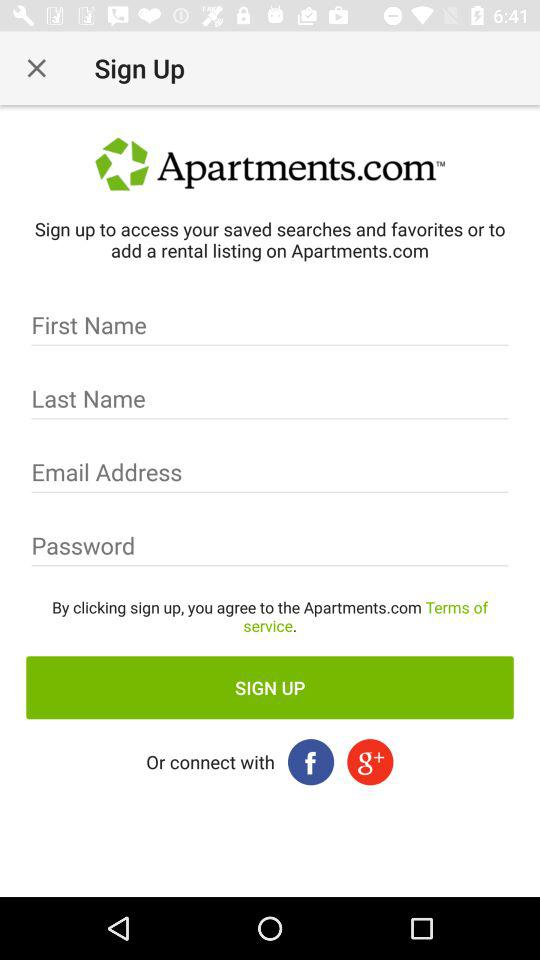What is the name of the application? The name of the application is "Apartments.com". 